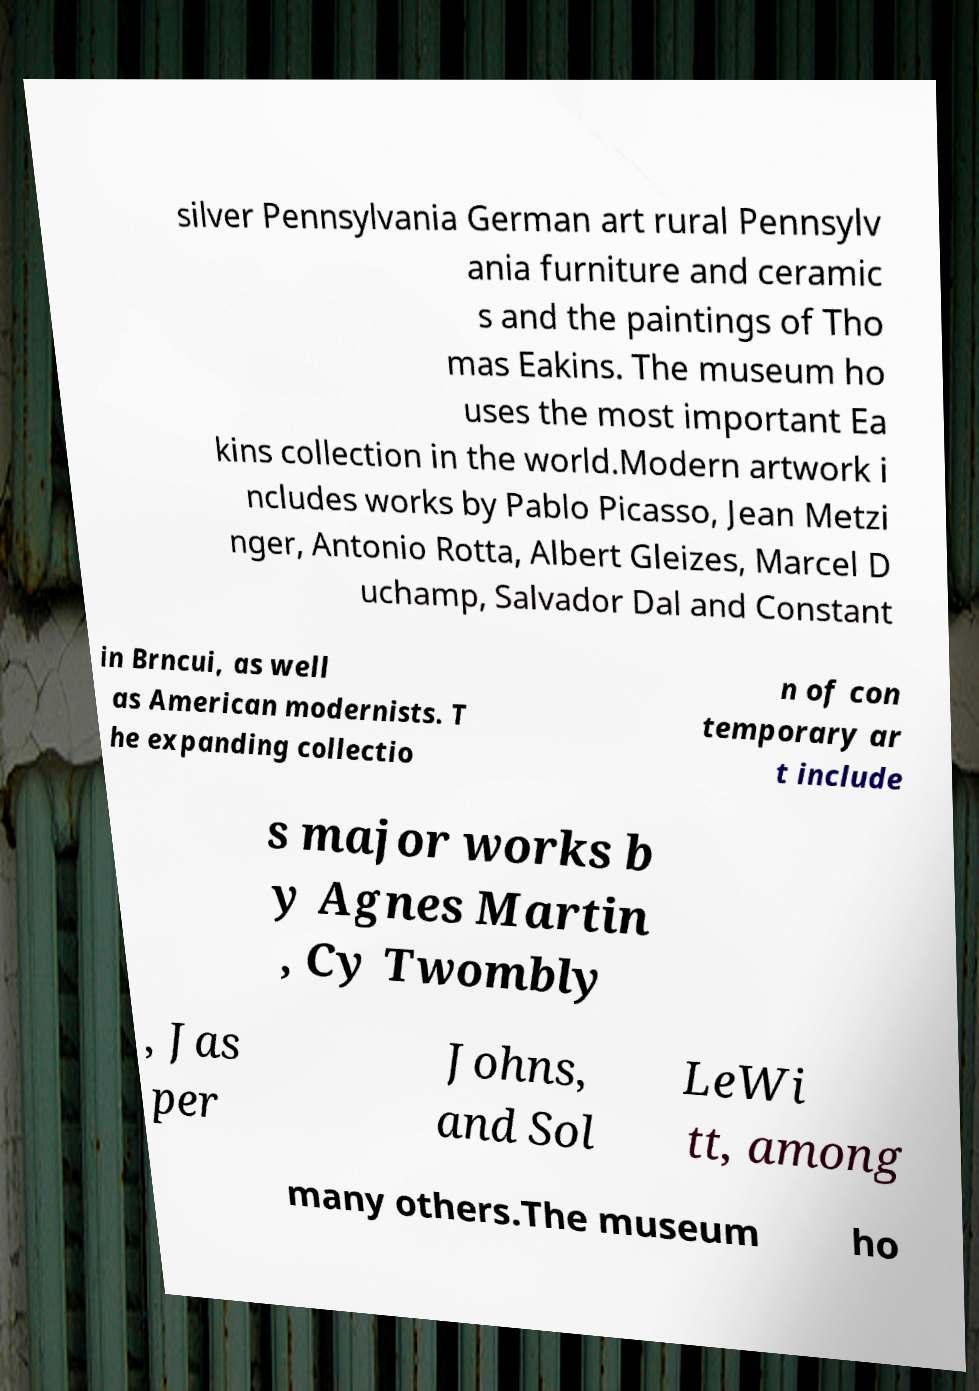Please read and relay the text visible in this image. What does it say? silver Pennsylvania German art rural Pennsylv ania furniture and ceramic s and the paintings of Tho mas Eakins. The museum ho uses the most important Ea kins collection in the world.Modern artwork i ncludes works by Pablo Picasso, Jean Metzi nger, Antonio Rotta, Albert Gleizes, Marcel D uchamp, Salvador Dal and Constant in Brncui, as well as American modernists. T he expanding collectio n of con temporary ar t include s major works b y Agnes Martin , Cy Twombly , Jas per Johns, and Sol LeWi tt, among many others.The museum ho 